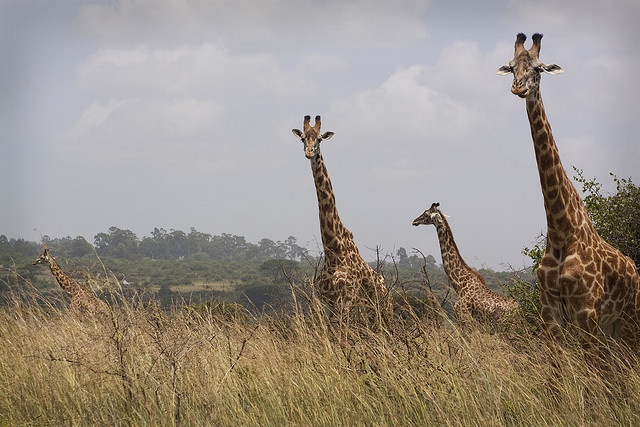Describe the objects in this image and their specific colors. I can see giraffe in darkgray, black, maroon, and gray tones, giraffe in darkgray, maroon, black, and gray tones, giraffe in darkgray, maroon, and gray tones, and giraffe in darkgray, gray, tan, and maroon tones in this image. 